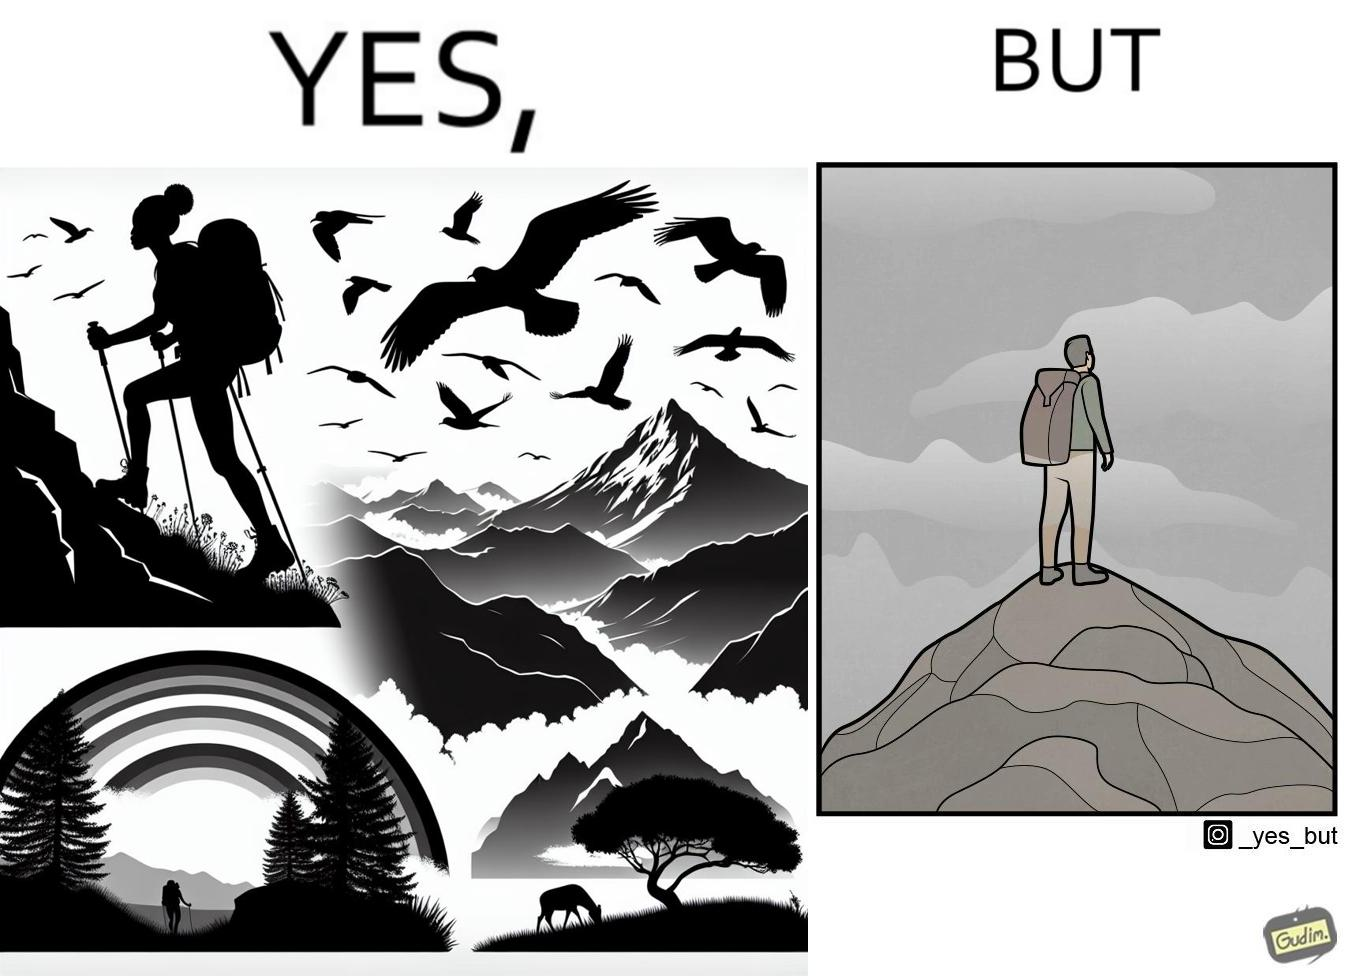What is shown in this image? The image is ironic, because the mountaineer climbs up the mountain to view the world from the peak but due to so much cloud, at the top, nothing is visible whereas he was able to witness some awesome views while climbing up the mountain 